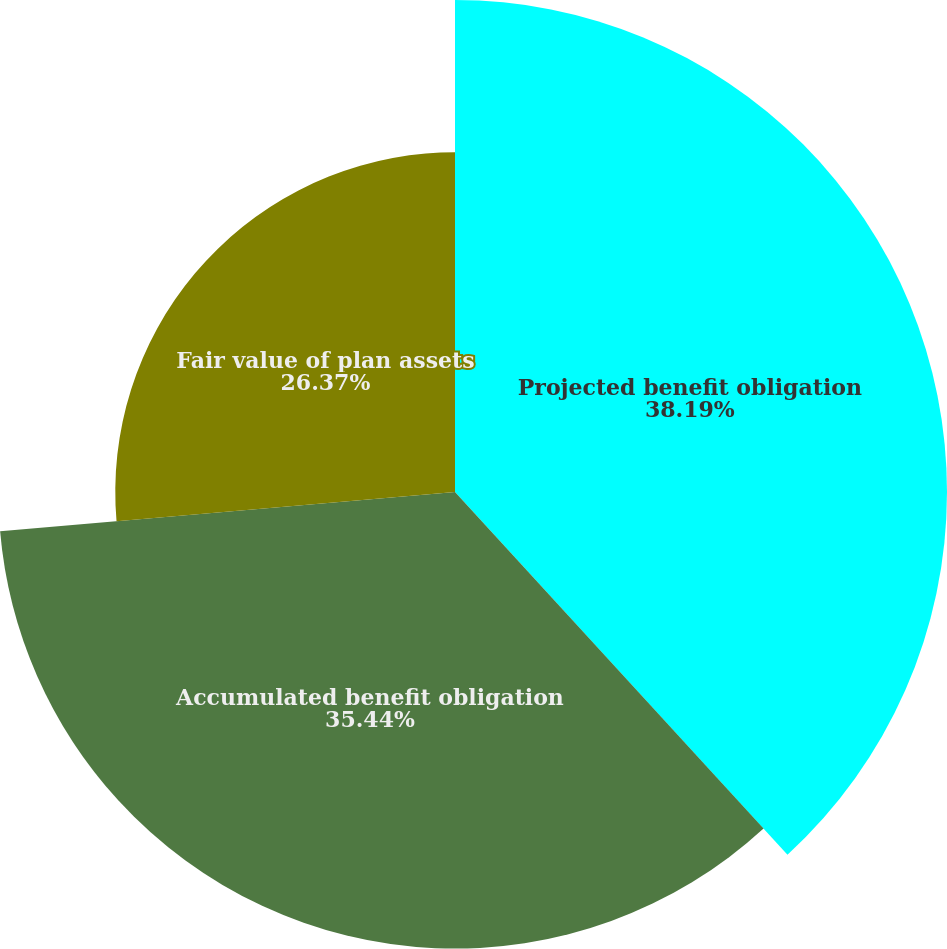Convert chart to OTSL. <chart><loc_0><loc_0><loc_500><loc_500><pie_chart><fcel>Projected benefit obligation<fcel>Accumulated benefit obligation<fcel>Fair value of plan assets<nl><fcel>38.19%<fcel>35.44%<fcel>26.37%<nl></chart> 